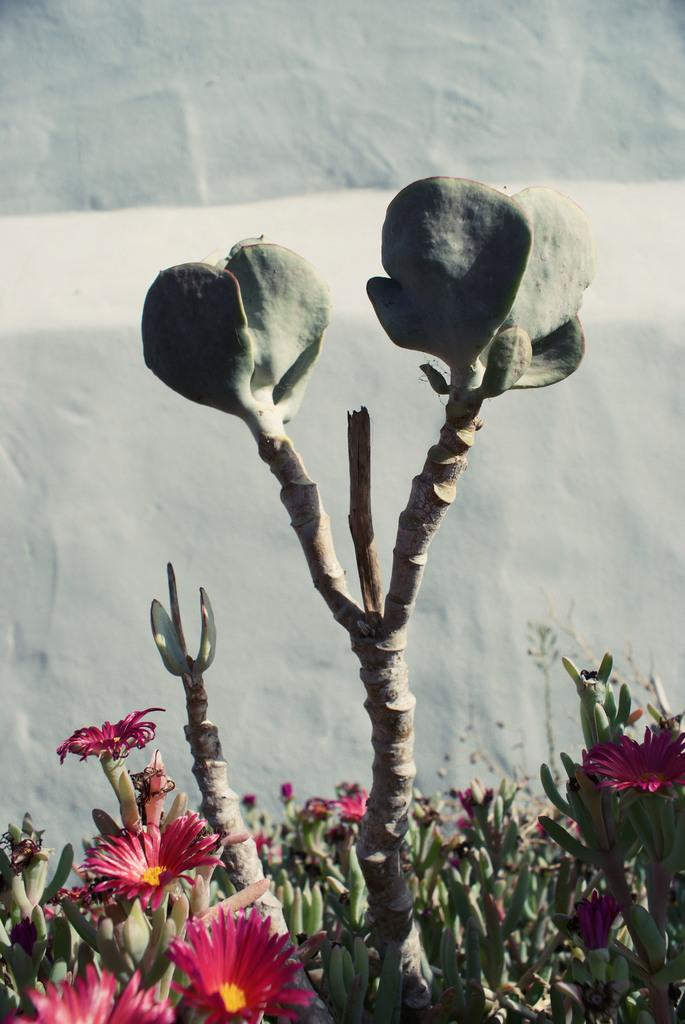What type of plants can be seen in the image? There are flower plants and a non-flowering plant in the image. What is visible in the background of the image? There is a white wall in the background of the image. How does the hook help the plants grow in the image? There is no hook present in the image; it only features plants and a white wall in the background. 